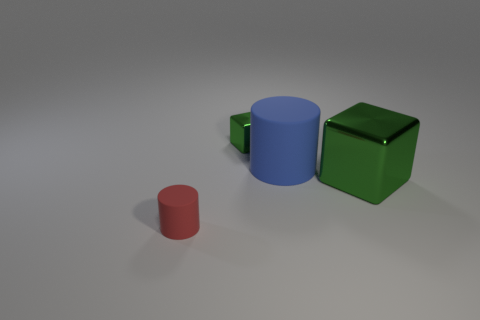Add 1 large blue cylinders. How many objects exist? 5 Subtract 0 purple cubes. How many objects are left? 4 Subtract all large cylinders. Subtract all blocks. How many objects are left? 1 Add 3 rubber things. How many rubber things are left? 5 Add 4 blue matte cylinders. How many blue matte cylinders exist? 5 